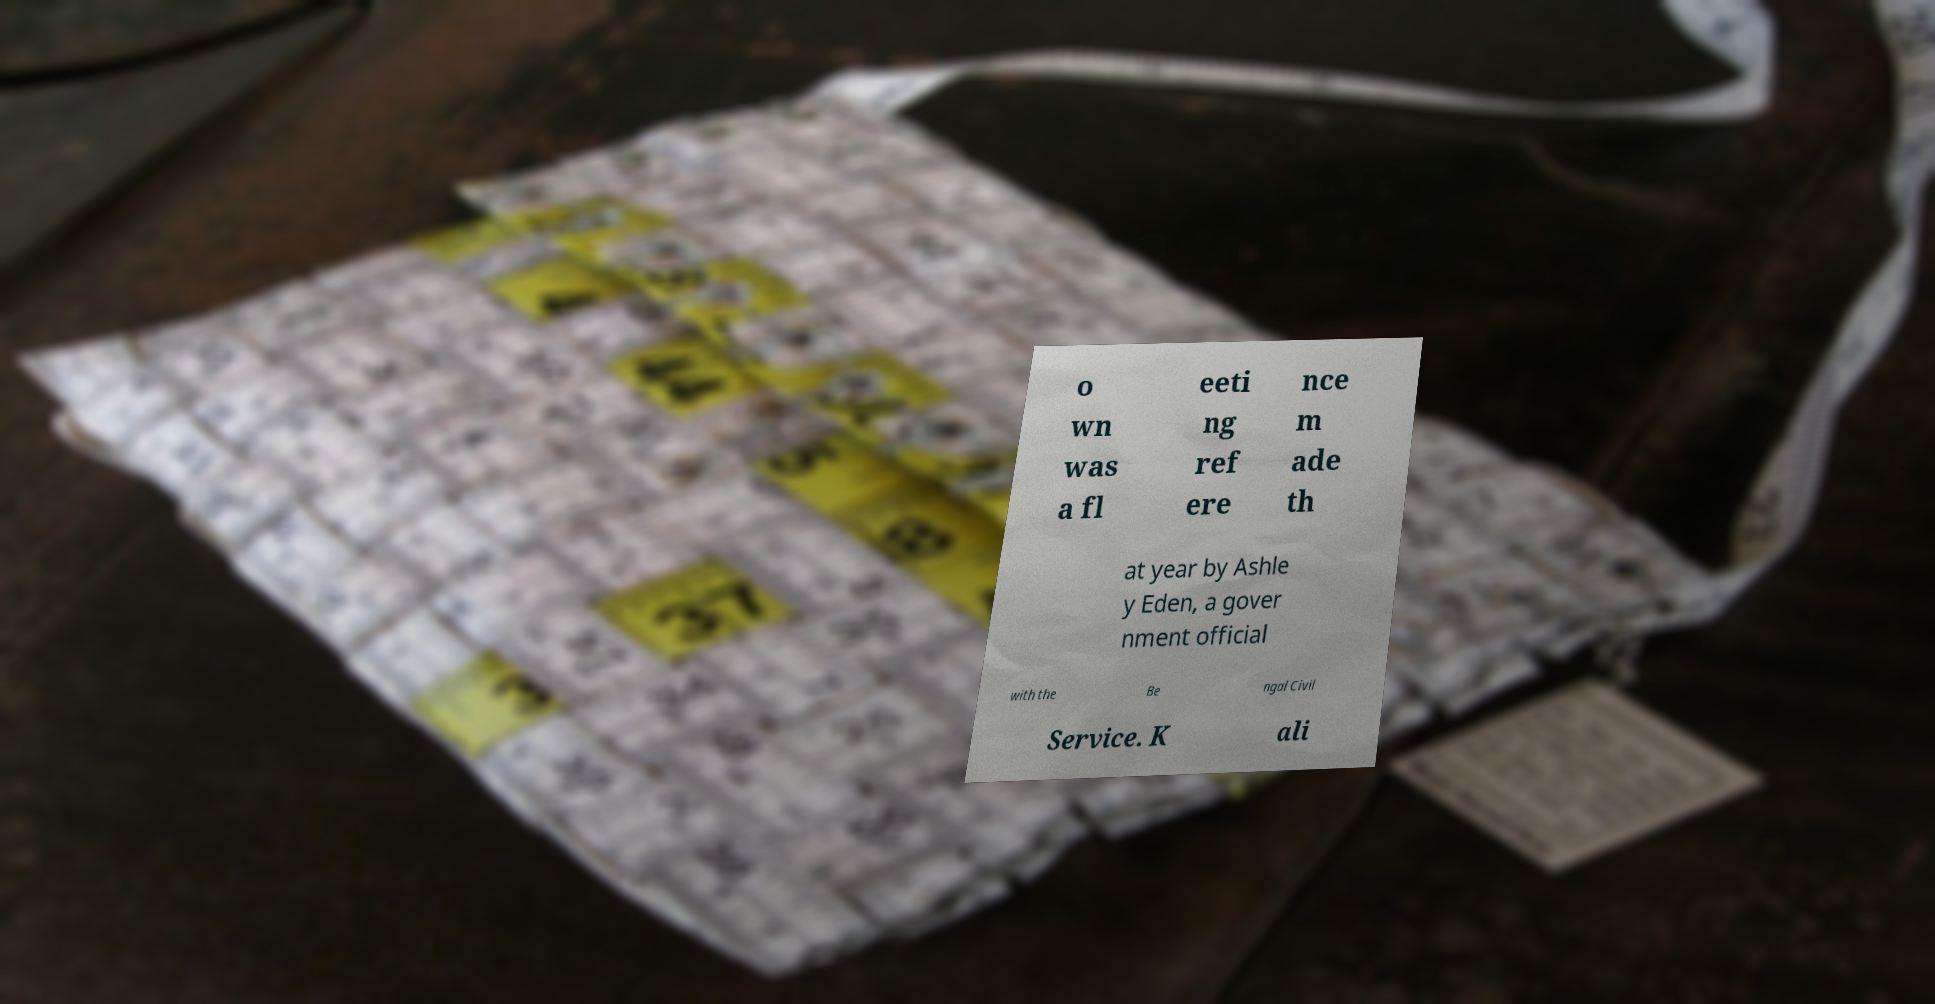What messages or text are displayed in this image? I need them in a readable, typed format. o wn was a fl eeti ng ref ere nce m ade th at year by Ashle y Eden, a gover nment official with the Be ngal Civil Service. K ali 